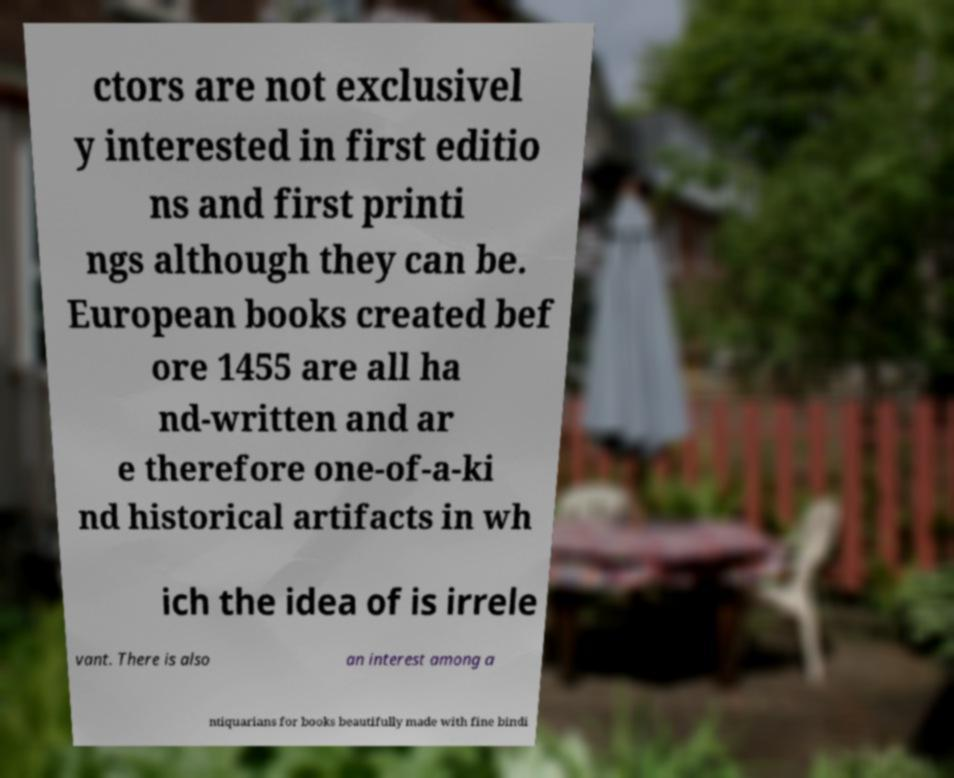What messages or text are displayed in this image? I need them in a readable, typed format. ctors are not exclusivel y interested in first editio ns and first printi ngs although they can be. European books created bef ore 1455 are all ha nd-written and ar e therefore one-of-a-ki nd historical artifacts in wh ich the idea of is irrele vant. There is also an interest among a ntiquarians for books beautifully made with fine bindi 